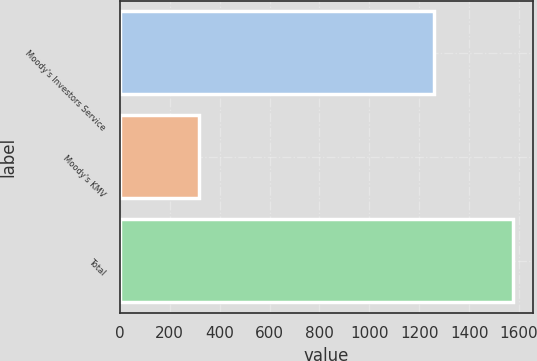Convert chart to OTSL. <chart><loc_0><loc_0><loc_500><loc_500><bar_chart><fcel>Moody's Investors Service<fcel>Moody's KMV<fcel>Total<nl><fcel>1258<fcel>318<fcel>1576<nl></chart> 